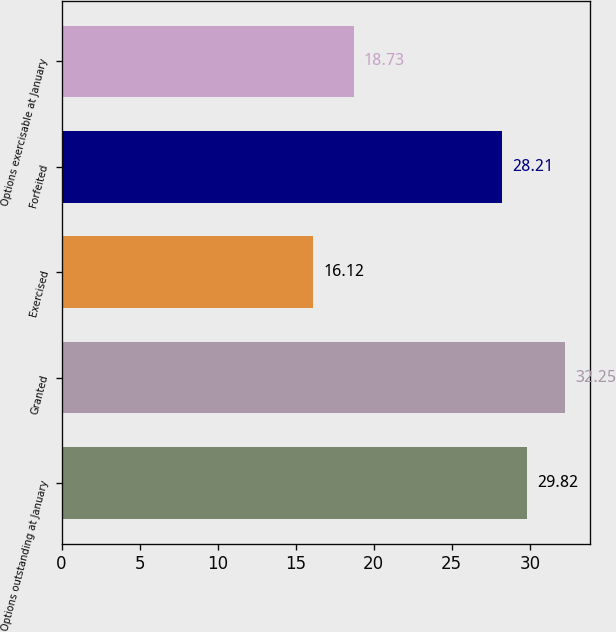Convert chart to OTSL. <chart><loc_0><loc_0><loc_500><loc_500><bar_chart><fcel>Options outstanding at January<fcel>Granted<fcel>Exercised<fcel>Forfeited<fcel>Options exercisable at January<nl><fcel>29.82<fcel>32.25<fcel>16.12<fcel>28.21<fcel>18.73<nl></chart> 